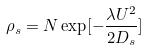Convert formula to latex. <formula><loc_0><loc_0><loc_500><loc_500>\rho _ { s } = N \exp [ - \frac { \lambda U ^ { 2 } } { 2 D _ { s } } ]</formula> 